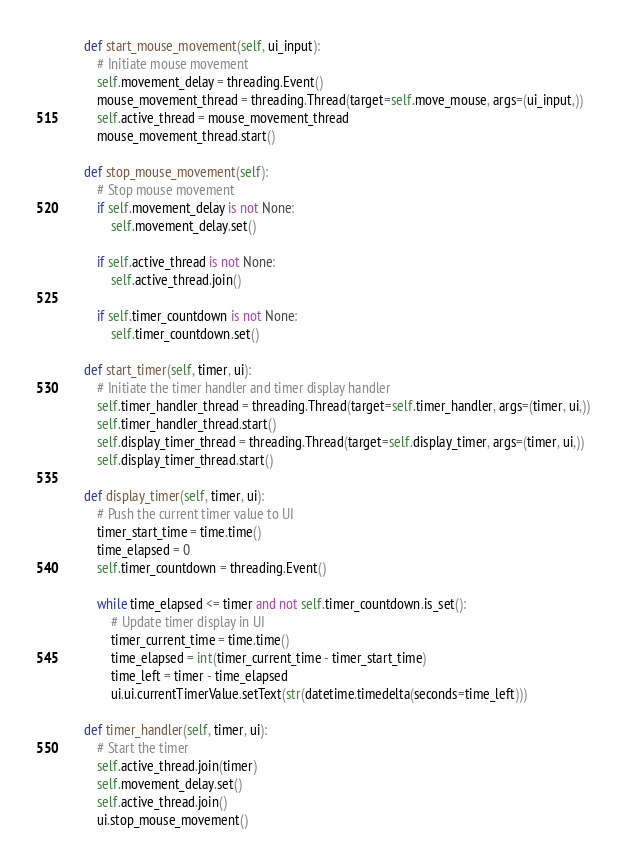<code> <loc_0><loc_0><loc_500><loc_500><_Python_>    def start_mouse_movement(self, ui_input):
        # Initiate mouse movement
        self.movement_delay = threading.Event()
        mouse_movement_thread = threading.Thread(target=self.move_mouse, args=(ui_input,))
        self.active_thread = mouse_movement_thread
        mouse_movement_thread.start()
    
    def stop_mouse_movement(self):
        # Stop mouse movement
        if self.movement_delay is not None:
            self.movement_delay.set()
        
        if self.active_thread is not None:
            self.active_thread.join()
        
        if self.timer_countdown is not None:
            self.timer_countdown.set()
    
    def start_timer(self, timer, ui):
        # Initiate the timer handler and timer display handler
        self.timer_handler_thread = threading.Thread(target=self.timer_handler, args=(timer, ui,))
        self.timer_handler_thread.start()
        self.display_timer_thread = threading.Thread(target=self.display_timer, args=(timer, ui,))
        self.display_timer_thread.start()
    
    def display_timer(self, timer, ui):
        # Push the current timer value to UI
        timer_start_time = time.time()
        time_elapsed = 0
        self.timer_countdown = threading.Event()
        
        while time_elapsed <= timer and not self.timer_countdown.is_set():
            # Update timer display in UI
            timer_current_time = time.time()
            time_elapsed = int(timer_current_time - timer_start_time)
            time_left = timer - time_elapsed
            ui.ui.currentTimerValue.setText(str(datetime.timedelta(seconds=time_left)))

    def timer_handler(self, timer, ui):
        # Start the timer
        self.active_thread.join(timer)
        self.movement_delay.set()
        self.active_thread.join()
        ui.stop_mouse_movement()
</code> 